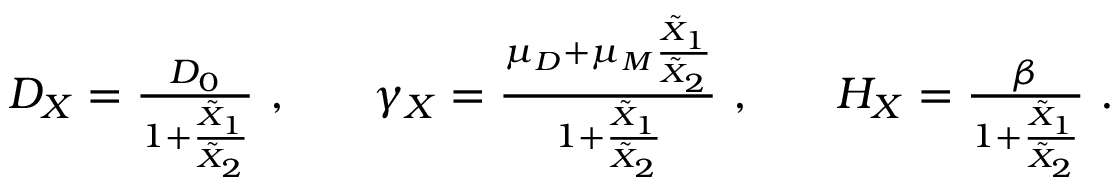Convert formula to latex. <formula><loc_0><loc_0><loc_500><loc_500>\begin{array} { r l r l r } { D _ { X } = \frac { D _ { 0 } } { 1 + \frac { \tilde { X } _ { 1 } } { \tilde { X } _ { 2 } } } , } & { \gamma _ { X } = \frac { \mu _ { D } + \mu _ { M } \frac { \tilde { X } _ { 1 } } { \tilde { X } _ { 2 } } } { 1 + \frac { \tilde { X } _ { 1 } } { \tilde { X } _ { 2 } } } , } & { H _ { X } = \frac { \beta } { 1 + \frac { \tilde { X } _ { 1 } } { \tilde { X } _ { 2 } } } . } \end{array}</formula> 